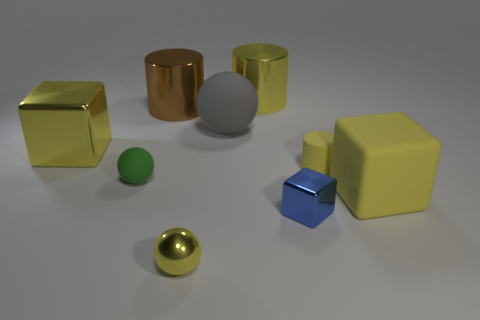Do the big brown cylinder and the large ball that is behind the green matte object have the same material?
Your response must be concise. No. There is a matte object that is behind the green matte object and to the right of the gray ball; what color is it?
Ensure brevity in your answer.  Yellow. What number of cylinders are either large shiny objects or tiny yellow objects?
Provide a succinct answer. 3. Do the tiny blue metal thing and the small green thing left of the big gray thing have the same shape?
Give a very brief answer. No. There is a thing that is to the left of the brown cylinder and on the right side of the yellow metal block; what size is it?
Provide a short and direct response. Small. The big brown thing has what shape?
Your answer should be compact. Cylinder. Is there a brown cylinder in front of the yellow metal object on the left side of the green thing?
Provide a short and direct response. No. How many large brown things are behind the sphere in front of the green rubber ball?
Provide a succinct answer. 1. There is a green object that is the same size as the matte cylinder; what material is it?
Offer a very short reply. Rubber. There is a large object that is in front of the green thing; is its shape the same as the tiny yellow metallic object?
Make the answer very short. No. 